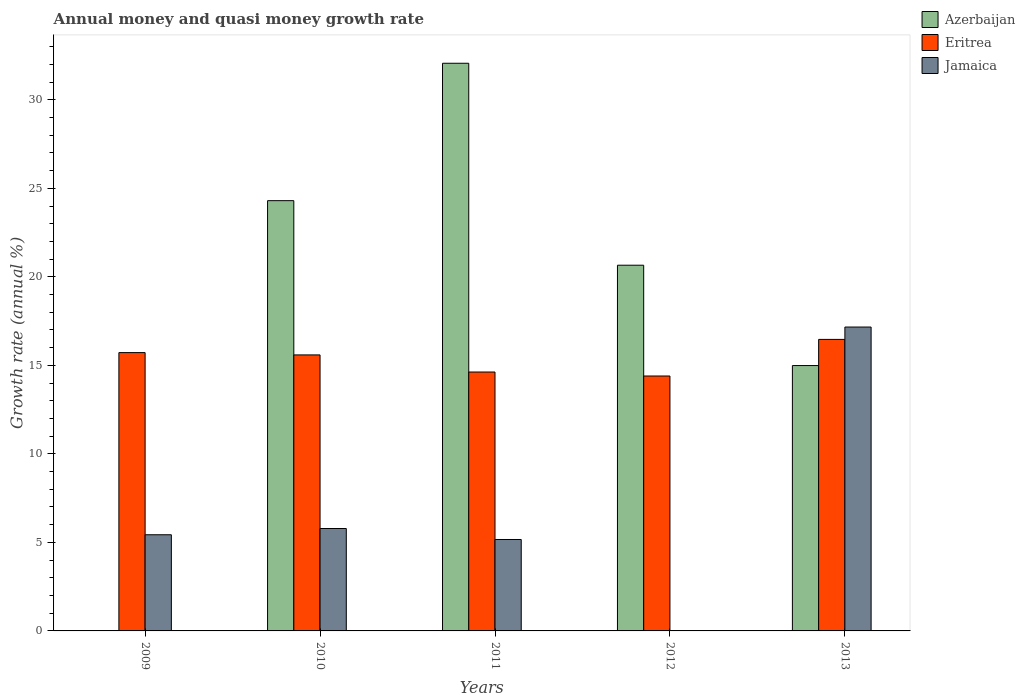How many different coloured bars are there?
Give a very brief answer. 3. Are the number of bars on each tick of the X-axis equal?
Provide a short and direct response. No. How many bars are there on the 4th tick from the left?
Your answer should be compact. 2. How many bars are there on the 4th tick from the right?
Offer a very short reply. 3. What is the label of the 2nd group of bars from the left?
Ensure brevity in your answer.  2010. In how many cases, is the number of bars for a given year not equal to the number of legend labels?
Your response must be concise. 2. What is the growth rate in Azerbaijan in 2011?
Ensure brevity in your answer.  32.07. Across all years, what is the maximum growth rate in Eritrea?
Your answer should be compact. 16.47. Across all years, what is the minimum growth rate in Jamaica?
Offer a terse response. 0. In which year was the growth rate in Eritrea maximum?
Make the answer very short. 2013. What is the total growth rate in Azerbaijan in the graph?
Give a very brief answer. 92.02. What is the difference between the growth rate in Eritrea in 2009 and that in 2012?
Your response must be concise. 1.32. What is the difference between the growth rate in Azerbaijan in 2010 and the growth rate in Eritrea in 2009?
Your answer should be compact. 8.58. What is the average growth rate in Jamaica per year?
Offer a very short reply. 6.71. In the year 2010, what is the difference between the growth rate in Azerbaijan and growth rate in Jamaica?
Your response must be concise. 18.52. In how many years, is the growth rate in Azerbaijan greater than 7 %?
Make the answer very short. 4. What is the ratio of the growth rate in Azerbaijan in 2012 to that in 2013?
Give a very brief answer. 1.38. Is the growth rate in Azerbaijan in 2010 less than that in 2011?
Provide a succinct answer. Yes. Is the difference between the growth rate in Azerbaijan in 2011 and 2013 greater than the difference between the growth rate in Jamaica in 2011 and 2013?
Offer a very short reply. Yes. What is the difference between the highest and the second highest growth rate in Eritrea?
Your answer should be very brief. 0.75. What is the difference between the highest and the lowest growth rate in Eritrea?
Keep it short and to the point. 2.07. In how many years, is the growth rate in Eritrea greater than the average growth rate in Eritrea taken over all years?
Provide a succinct answer. 3. Is the sum of the growth rate in Jamaica in 2009 and 2013 greater than the maximum growth rate in Azerbaijan across all years?
Give a very brief answer. No. Is it the case that in every year, the sum of the growth rate in Jamaica and growth rate in Azerbaijan is greater than the growth rate in Eritrea?
Offer a very short reply. No. How many bars are there?
Your response must be concise. 13. How many years are there in the graph?
Give a very brief answer. 5. What is the difference between two consecutive major ticks on the Y-axis?
Keep it short and to the point. 5. Are the values on the major ticks of Y-axis written in scientific E-notation?
Your answer should be compact. No. Does the graph contain any zero values?
Provide a short and direct response. Yes. How are the legend labels stacked?
Provide a short and direct response. Vertical. What is the title of the graph?
Provide a succinct answer. Annual money and quasi money growth rate. Does "Cabo Verde" appear as one of the legend labels in the graph?
Ensure brevity in your answer.  No. What is the label or title of the X-axis?
Your answer should be very brief. Years. What is the label or title of the Y-axis?
Your answer should be compact. Growth rate (annual %). What is the Growth rate (annual %) in Azerbaijan in 2009?
Offer a terse response. 0. What is the Growth rate (annual %) in Eritrea in 2009?
Provide a succinct answer. 15.72. What is the Growth rate (annual %) in Jamaica in 2009?
Provide a succinct answer. 5.43. What is the Growth rate (annual %) of Azerbaijan in 2010?
Your response must be concise. 24.3. What is the Growth rate (annual %) of Eritrea in 2010?
Your answer should be very brief. 15.59. What is the Growth rate (annual %) in Jamaica in 2010?
Offer a terse response. 5.79. What is the Growth rate (annual %) of Azerbaijan in 2011?
Ensure brevity in your answer.  32.07. What is the Growth rate (annual %) in Eritrea in 2011?
Your answer should be very brief. 14.62. What is the Growth rate (annual %) of Jamaica in 2011?
Make the answer very short. 5.16. What is the Growth rate (annual %) in Azerbaijan in 2012?
Provide a succinct answer. 20.66. What is the Growth rate (annual %) in Eritrea in 2012?
Offer a very short reply. 14.4. What is the Growth rate (annual %) of Jamaica in 2012?
Provide a short and direct response. 0. What is the Growth rate (annual %) of Azerbaijan in 2013?
Offer a very short reply. 14.99. What is the Growth rate (annual %) in Eritrea in 2013?
Provide a short and direct response. 16.47. What is the Growth rate (annual %) of Jamaica in 2013?
Your answer should be compact. 17.17. Across all years, what is the maximum Growth rate (annual %) in Azerbaijan?
Provide a succinct answer. 32.07. Across all years, what is the maximum Growth rate (annual %) of Eritrea?
Provide a succinct answer. 16.47. Across all years, what is the maximum Growth rate (annual %) of Jamaica?
Give a very brief answer. 17.17. Across all years, what is the minimum Growth rate (annual %) of Azerbaijan?
Ensure brevity in your answer.  0. Across all years, what is the minimum Growth rate (annual %) of Eritrea?
Your answer should be compact. 14.4. What is the total Growth rate (annual %) in Azerbaijan in the graph?
Make the answer very short. 92.02. What is the total Growth rate (annual %) in Eritrea in the graph?
Keep it short and to the point. 76.8. What is the total Growth rate (annual %) in Jamaica in the graph?
Make the answer very short. 33.55. What is the difference between the Growth rate (annual %) of Eritrea in 2009 and that in 2010?
Make the answer very short. 0.13. What is the difference between the Growth rate (annual %) in Jamaica in 2009 and that in 2010?
Give a very brief answer. -0.35. What is the difference between the Growth rate (annual %) in Eritrea in 2009 and that in 2011?
Provide a succinct answer. 1.1. What is the difference between the Growth rate (annual %) in Jamaica in 2009 and that in 2011?
Keep it short and to the point. 0.27. What is the difference between the Growth rate (annual %) of Eritrea in 2009 and that in 2012?
Keep it short and to the point. 1.32. What is the difference between the Growth rate (annual %) of Eritrea in 2009 and that in 2013?
Provide a short and direct response. -0.75. What is the difference between the Growth rate (annual %) in Jamaica in 2009 and that in 2013?
Provide a short and direct response. -11.73. What is the difference between the Growth rate (annual %) of Azerbaijan in 2010 and that in 2011?
Offer a terse response. -7.76. What is the difference between the Growth rate (annual %) in Eritrea in 2010 and that in 2011?
Make the answer very short. 0.97. What is the difference between the Growth rate (annual %) of Jamaica in 2010 and that in 2011?
Ensure brevity in your answer.  0.62. What is the difference between the Growth rate (annual %) of Azerbaijan in 2010 and that in 2012?
Provide a succinct answer. 3.65. What is the difference between the Growth rate (annual %) of Eritrea in 2010 and that in 2012?
Keep it short and to the point. 1.19. What is the difference between the Growth rate (annual %) in Azerbaijan in 2010 and that in 2013?
Make the answer very short. 9.31. What is the difference between the Growth rate (annual %) in Eritrea in 2010 and that in 2013?
Provide a succinct answer. -0.88. What is the difference between the Growth rate (annual %) of Jamaica in 2010 and that in 2013?
Your answer should be compact. -11.38. What is the difference between the Growth rate (annual %) in Azerbaijan in 2011 and that in 2012?
Offer a very short reply. 11.41. What is the difference between the Growth rate (annual %) in Eritrea in 2011 and that in 2012?
Make the answer very short. 0.22. What is the difference between the Growth rate (annual %) in Azerbaijan in 2011 and that in 2013?
Your answer should be compact. 17.08. What is the difference between the Growth rate (annual %) in Eritrea in 2011 and that in 2013?
Your response must be concise. -1.84. What is the difference between the Growth rate (annual %) in Jamaica in 2011 and that in 2013?
Keep it short and to the point. -12. What is the difference between the Growth rate (annual %) in Azerbaijan in 2012 and that in 2013?
Ensure brevity in your answer.  5.67. What is the difference between the Growth rate (annual %) in Eritrea in 2012 and that in 2013?
Offer a very short reply. -2.07. What is the difference between the Growth rate (annual %) in Eritrea in 2009 and the Growth rate (annual %) in Jamaica in 2010?
Provide a short and direct response. 9.94. What is the difference between the Growth rate (annual %) in Eritrea in 2009 and the Growth rate (annual %) in Jamaica in 2011?
Provide a short and direct response. 10.56. What is the difference between the Growth rate (annual %) of Eritrea in 2009 and the Growth rate (annual %) of Jamaica in 2013?
Keep it short and to the point. -1.44. What is the difference between the Growth rate (annual %) of Azerbaijan in 2010 and the Growth rate (annual %) of Eritrea in 2011?
Ensure brevity in your answer.  9.68. What is the difference between the Growth rate (annual %) in Azerbaijan in 2010 and the Growth rate (annual %) in Jamaica in 2011?
Your answer should be very brief. 19.14. What is the difference between the Growth rate (annual %) of Eritrea in 2010 and the Growth rate (annual %) of Jamaica in 2011?
Provide a short and direct response. 10.43. What is the difference between the Growth rate (annual %) in Azerbaijan in 2010 and the Growth rate (annual %) in Eritrea in 2012?
Offer a very short reply. 9.9. What is the difference between the Growth rate (annual %) in Azerbaijan in 2010 and the Growth rate (annual %) in Eritrea in 2013?
Your answer should be compact. 7.84. What is the difference between the Growth rate (annual %) in Azerbaijan in 2010 and the Growth rate (annual %) in Jamaica in 2013?
Keep it short and to the point. 7.14. What is the difference between the Growth rate (annual %) of Eritrea in 2010 and the Growth rate (annual %) of Jamaica in 2013?
Provide a succinct answer. -1.57. What is the difference between the Growth rate (annual %) in Azerbaijan in 2011 and the Growth rate (annual %) in Eritrea in 2012?
Keep it short and to the point. 17.67. What is the difference between the Growth rate (annual %) of Azerbaijan in 2011 and the Growth rate (annual %) of Eritrea in 2013?
Provide a short and direct response. 15.6. What is the difference between the Growth rate (annual %) of Azerbaijan in 2011 and the Growth rate (annual %) of Jamaica in 2013?
Give a very brief answer. 14.9. What is the difference between the Growth rate (annual %) of Eritrea in 2011 and the Growth rate (annual %) of Jamaica in 2013?
Give a very brief answer. -2.54. What is the difference between the Growth rate (annual %) of Azerbaijan in 2012 and the Growth rate (annual %) of Eritrea in 2013?
Offer a terse response. 4.19. What is the difference between the Growth rate (annual %) in Azerbaijan in 2012 and the Growth rate (annual %) in Jamaica in 2013?
Provide a succinct answer. 3.49. What is the difference between the Growth rate (annual %) in Eritrea in 2012 and the Growth rate (annual %) in Jamaica in 2013?
Your answer should be compact. -2.77. What is the average Growth rate (annual %) of Azerbaijan per year?
Your answer should be compact. 18.4. What is the average Growth rate (annual %) in Eritrea per year?
Provide a short and direct response. 15.36. What is the average Growth rate (annual %) of Jamaica per year?
Your answer should be very brief. 6.71. In the year 2009, what is the difference between the Growth rate (annual %) of Eritrea and Growth rate (annual %) of Jamaica?
Your answer should be compact. 10.29. In the year 2010, what is the difference between the Growth rate (annual %) in Azerbaijan and Growth rate (annual %) in Eritrea?
Give a very brief answer. 8.71. In the year 2010, what is the difference between the Growth rate (annual %) in Azerbaijan and Growth rate (annual %) in Jamaica?
Your answer should be compact. 18.52. In the year 2010, what is the difference between the Growth rate (annual %) of Eritrea and Growth rate (annual %) of Jamaica?
Keep it short and to the point. 9.81. In the year 2011, what is the difference between the Growth rate (annual %) of Azerbaijan and Growth rate (annual %) of Eritrea?
Make the answer very short. 17.44. In the year 2011, what is the difference between the Growth rate (annual %) of Azerbaijan and Growth rate (annual %) of Jamaica?
Offer a very short reply. 26.9. In the year 2011, what is the difference between the Growth rate (annual %) of Eritrea and Growth rate (annual %) of Jamaica?
Give a very brief answer. 9.46. In the year 2012, what is the difference between the Growth rate (annual %) in Azerbaijan and Growth rate (annual %) in Eritrea?
Your answer should be very brief. 6.26. In the year 2013, what is the difference between the Growth rate (annual %) in Azerbaijan and Growth rate (annual %) in Eritrea?
Make the answer very short. -1.48. In the year 2013, what is the difference between the Growth rate (annual %) of Azerbaijan and Growth rate (annual %) of Jamaica?
Make the answer very short. -2.18. In the year 2013, what is the difference between the Growth rate (annual %) in Eritrea and Growth rate (annual %) in Jamaica?
Your answer should be very brief. -0.7. What is the ratio of the Growth rate (annual %) of Eritrea in 2009 to that in 2010?
Make the answer very short. 1.01. What is the ratio of the Growth rate (annual %) of Jamaica in 2009 to that in 2010?
Keep it short and to the point. 0.94. What is the ratio of the Growth rate (annual %) of Eritrea in 2009 to that in 2011?
Give a very brief answer. 1.07. What is the ratio of the Growth rate (annual %) in Jamaica in 2009 to that in 2011?
Offer a terse response. 1.05. What is the ratio of the Growth rate (annual %) in Eritrea in 2009 to that in 2012?
Your response must be concise. 1.09. What is the ratio of the Growth rate (annual %) of Eritrea in 2009 to that in 2013?
Offer a terse response. 0.95. What is the ratio of the Growth rate (annual %) in Jamaica in 2009 to that in 2013?
Give a very brief answer. 0.32. What is the ratio of the Growth rate (annual %) of Azerbaijan in 2010 to that in 2011?
Your response must be concise. 0.76. What is the ratio of the Growth rate (annual %) in Eritrea in 2010 to that in 2011?
Your answer should be compact. 1.07. What is the ratio of the Growth rate (annual %) in Jamaica in 2010 to that in 2011?
Provide a short and direct response. 1.12. What is the ratio of the Growth rate (annual %) of Azerbaijan in 2010 to that in 2012?
Keep it short and to the point. 1.18. What is the ratio of the Growth rate (annual %) in Eritrea in 2010 to that in 2012?
Offer a very short reply. 1.08. What is the ratio of the Growth rate (annual %) in Azerbaijan in 2010 to that in 2013?
Keep it short and to the point. 1.62. What is the ratio of the Growth rate (annual %) in Eritrea in 2010 to that in 2013?
Your answer should be very brief. 0.95. What is the ratio of the Growth rate (annual %) in Jamaica in 2010 to that in 2013?
Give a very brief answer. 0.34. What is the ratio of the Growth rate (annual %) in Azerbaijan in 2011 to that in 2012?
Make the answer very short. 1.55. What is the ratio of the Growth rate (annual %) in Eritrea in 2011 to that in 2012?
Provide a succinct answer. 1.02. What is the ratio of the Growth rate (annual %) in Azerbaijan in 2011 to that in 2013?
Your answer should be very brief. 2.14. What is the ratio of the Growth rate (annual %) of Eritrea in 2011 to that in 2013?
Give a very brief answer. 0.89. What is the ratio of the Growth rate (annual %) in Jamaica in 2011 to that in 2013?
Your response must be concise. 0.3. What is the ratio of the Growth rate (annual %) of Azerbaijan in 2012 to that in 2013?
Give a very brief answer. 1.38. What is the ratio of the Growth rate (annual %) of Eritrea in 2012 to that in 2013?
Offer a terse response. 0.87. What is the difference between the highest and the second highest Growth rate (annual %) of Azerbaijan?
Your response must be concise. 7.76. What is the difference between the highest and the second highest Growth rate (annual %) in Eritrea?
Make the answer very short. 0.75. What is the difference between the highest and the second highest Growth rate (annual %) of Jamaica?
Provide a succinct answer. 11.38. What is the difference between the highest and the lowest Growth rate (annual %) in Azerbaijan?
Make the answer very short. 32.07. What is the difference between the highest and the lowest Growth rate (annual %) of Eritrea?
Your response must be concise. 2.07. What is the difference between the highest and the lowest Growth rate (annual %) of Jamaica?
Your answer should be compact. 17.17. 